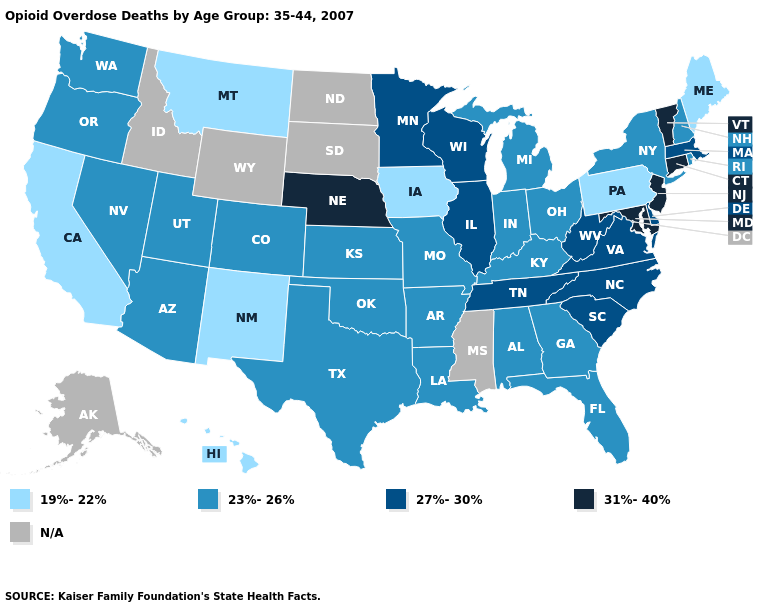Does the map have missing data?
Short answer required. Yes. What is the value of Idaho?
Be succinct. N/A. Which states have the lowest value in the MidWest?
Concise answer only. Iowa. Which states have the lowest value in the Northeast?
Answer briefly. Maine, Pennsylvania. Name the states that have a value in the range 27%-30%?
Be succinct. Delaware, Illinois, Massachusetts, Minnesota, North Carolina, South Carolina, Tennessee, Virginia, West Virginia, Wisconsin. Does Nebraska have the highest value in the MidWest?
Be succinct. Yes. What is the value of Utah?
Concise answer only. 23%-26%. Name the states that have a value in the range 31%-40%?
Give a very brief answer. Connecticut, Maryland, Nebraska, New Jersey, Vermont. What is the value of Kentucky?
Write a very short answer. 23%-26%. Among the states that border Arkansas , which have the lowest value?
Concise answer only. Louisiana, Missouri, Oklahoma, Texas. Name the states that have a value in the range 31%-40%?
Write a very short answer. Connecticut, Maryland, Nebraska, New Jersey, Vermont. What is the value of Montana?
Short answer required. 19%-22%. Among the states that border Maryland , which have the highest value?
Short answer required. Delaware, Virginia, West Virginia. 